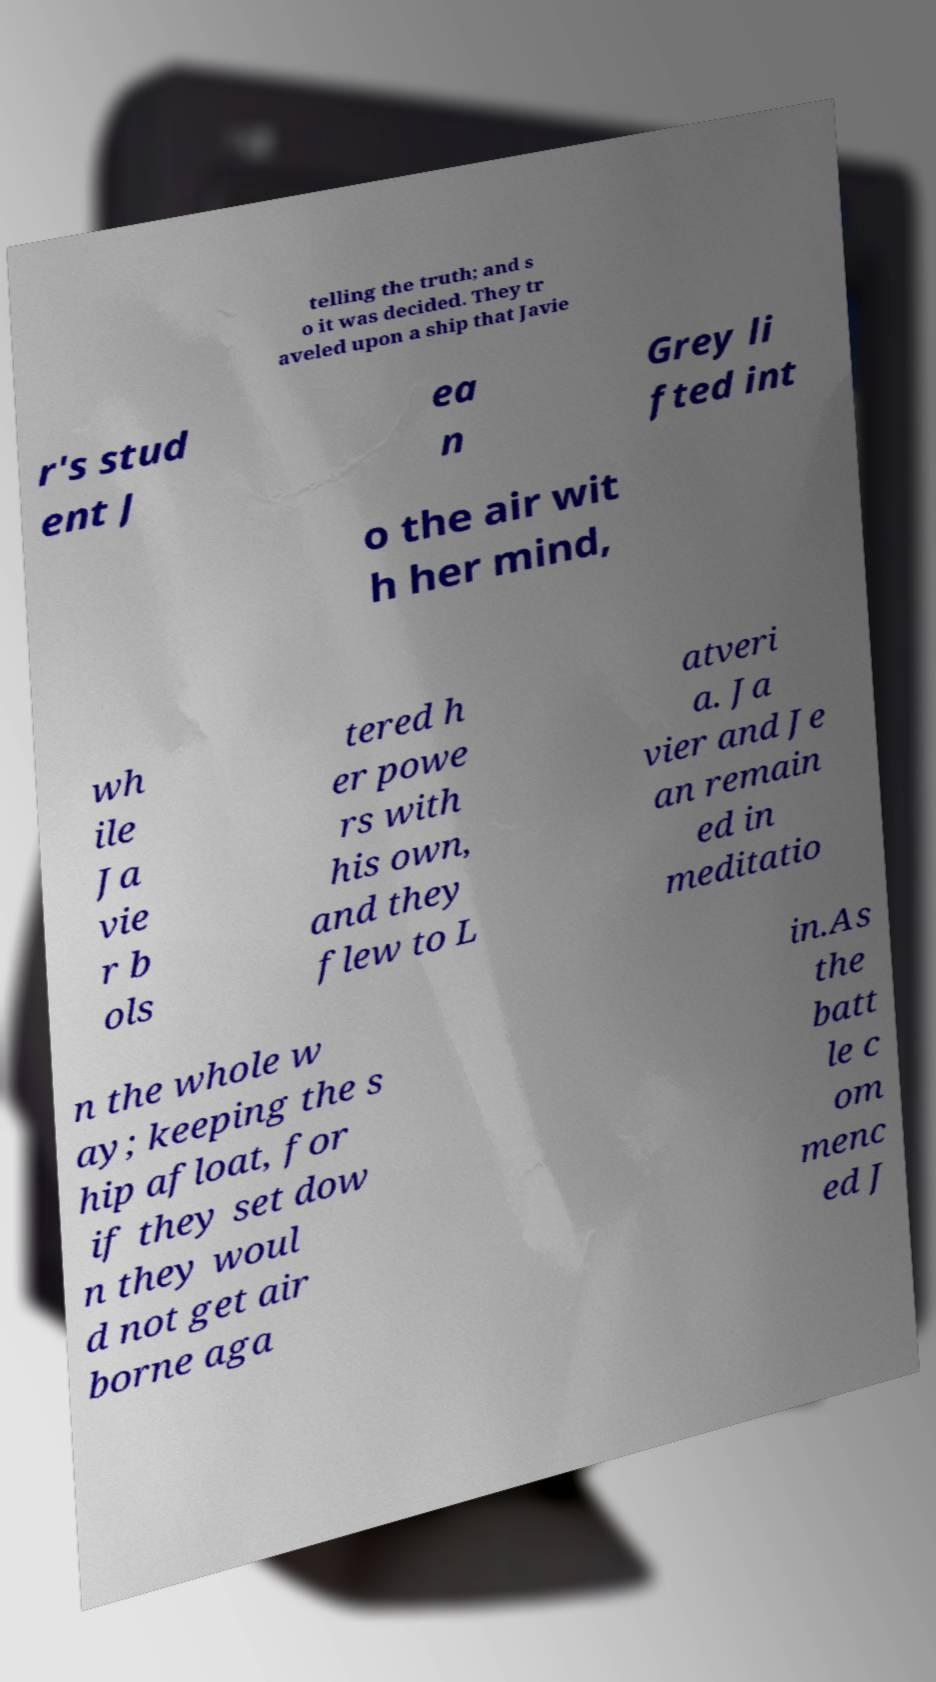Please read and relay the text visible in this image. What does it say? telling the truth; and s o it was decided. They tr aveled upon a ship that Javie r's stud ent J ea n Grey li fted int o the air wit h her mind, wh ile Ja vie r b ols tered h er powe rs with his own, and they flew to L atveri a. Ja vier and Je an remain ed in meditatio n the whole w ay; keeping the s hip afloat, for if they set dow n they woul d not get air borne aga in.As the batt le c om menc ed J 